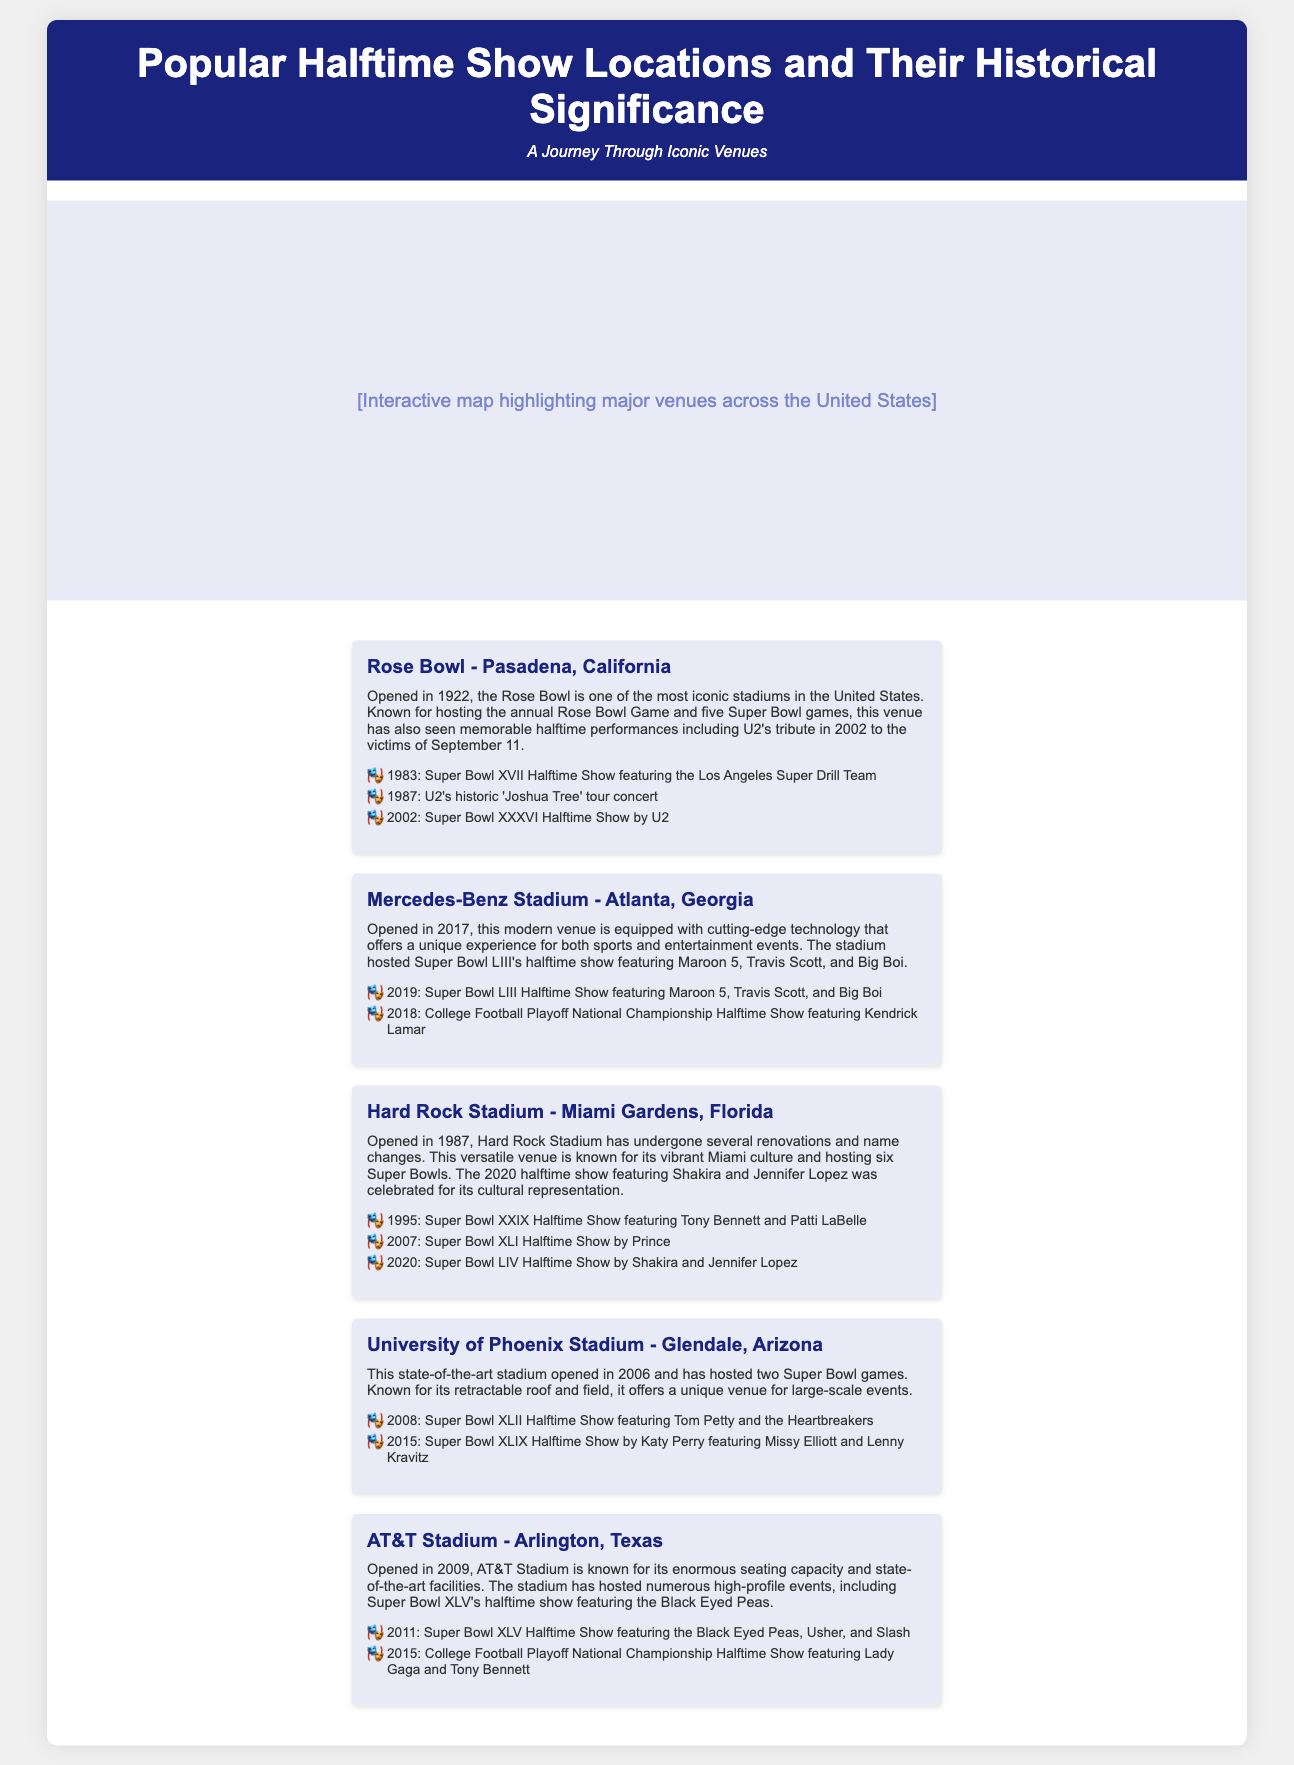What is the opening year of the Rose Bowl? The Rose Bowl opened in 1922, as mentioned in the location context.
Answer: 1922 Which venue hosted Super Bowl LIII? Super Bowl LIII was hosted at Mercedes-Benz Stadium, as stated in the key events.
Answer: Mercedes-Benz Stadium How many Super Bowls has Hard Rock Stadium hosted? The document states that Hard Rock Stadium has hosted six Super Bowls.
Answer: Six What significant performance did U2 give at the Rose Bowl? U2 performed a tribute to the victims of September 11 during the Super Bowl XXXVI Halftime Show in 2002.
Answer: Tribute to September 11 What is a unique feature of University of Phoenix Stadium? The stadium is known for its retractable roof, detailed in the location context.
Answer: Retractable roof What year did AT&T Stadium open? The document mentions that AT&T Stadium opened in 2009.
Answer: 2009 Which artist was featured in the 2020 halftime show at Hard Rock Stadium? The 2020 halftime show featured Shakira and Jennifer Lopez, according to the key events.
Answer: Shakira and Jennifer Lopez What was the halftime show featured in 2011 at AT&T Stadium? The halftime show in 2011 featured the Black Eyed Peas, Usher, and Slash, as per the key events.
Answer: Black Eyed Peas, Usher, and Slash 